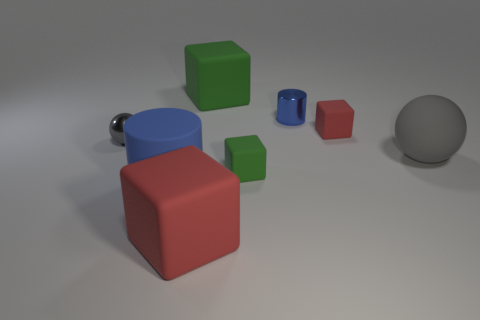Is the shape of the large green object the same as the red matte thing on the right side of the large red cube?
Your response must be concise. Yes. What is the material of the red block on the right side of the blue thing behind the big sphere behind the tiny green thing?
Your answer should be very brief. Rubber. What number of red matte cubes are there?
Make the answer very short. 2. What number of gray things are either shiny objects or tiny rubber cylinders?
Offer a terse response. 1. What number of other things are there of the same shape as the small gray object?
Ensure brevity in your answer.  1. There is a small rubber cube that is in front of the big gray ball; is its color the same as the sphere that is right of the blue matte cylinder?
Your answer should be compact. No. What number of tiny things are either blue cubes or gray shiny objects?
Ensure brevity in your answer.  1. What size is the other blue object that is the same shape as the big blue thing?
Your answer should be very brief. Small. Are there any other things that have the same size as the blue metallic cylinder?
Offer a terse response. Yes. There is a cylinder to the left of the red matte block to the left of the large green rubber object; what is it made of?
Your response must be concise. Rubber. 